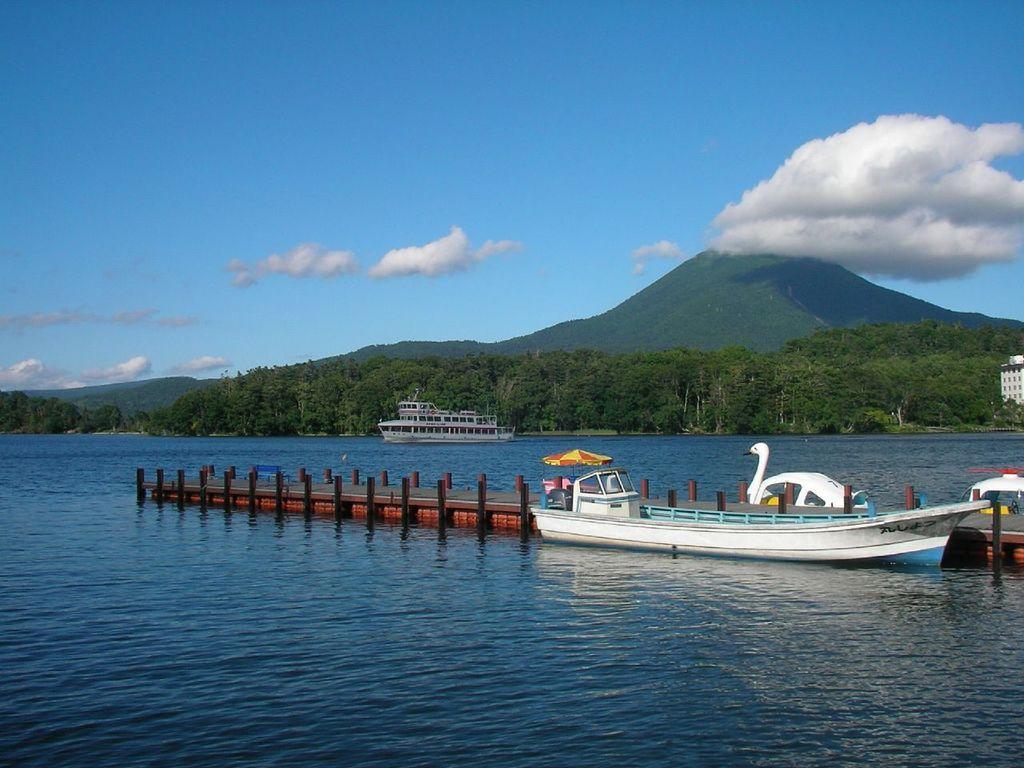Could you give a brief overview of what you see in this image? In this image there is a sea in the bottom of this image. There is a dock and a boat is in this sea as we can see in the bottom of this image. There is a ship in the middle of this image. There are some trees in the background. There is a mountain on the right side of this image. There is a cloudy sky on the top of this image. 